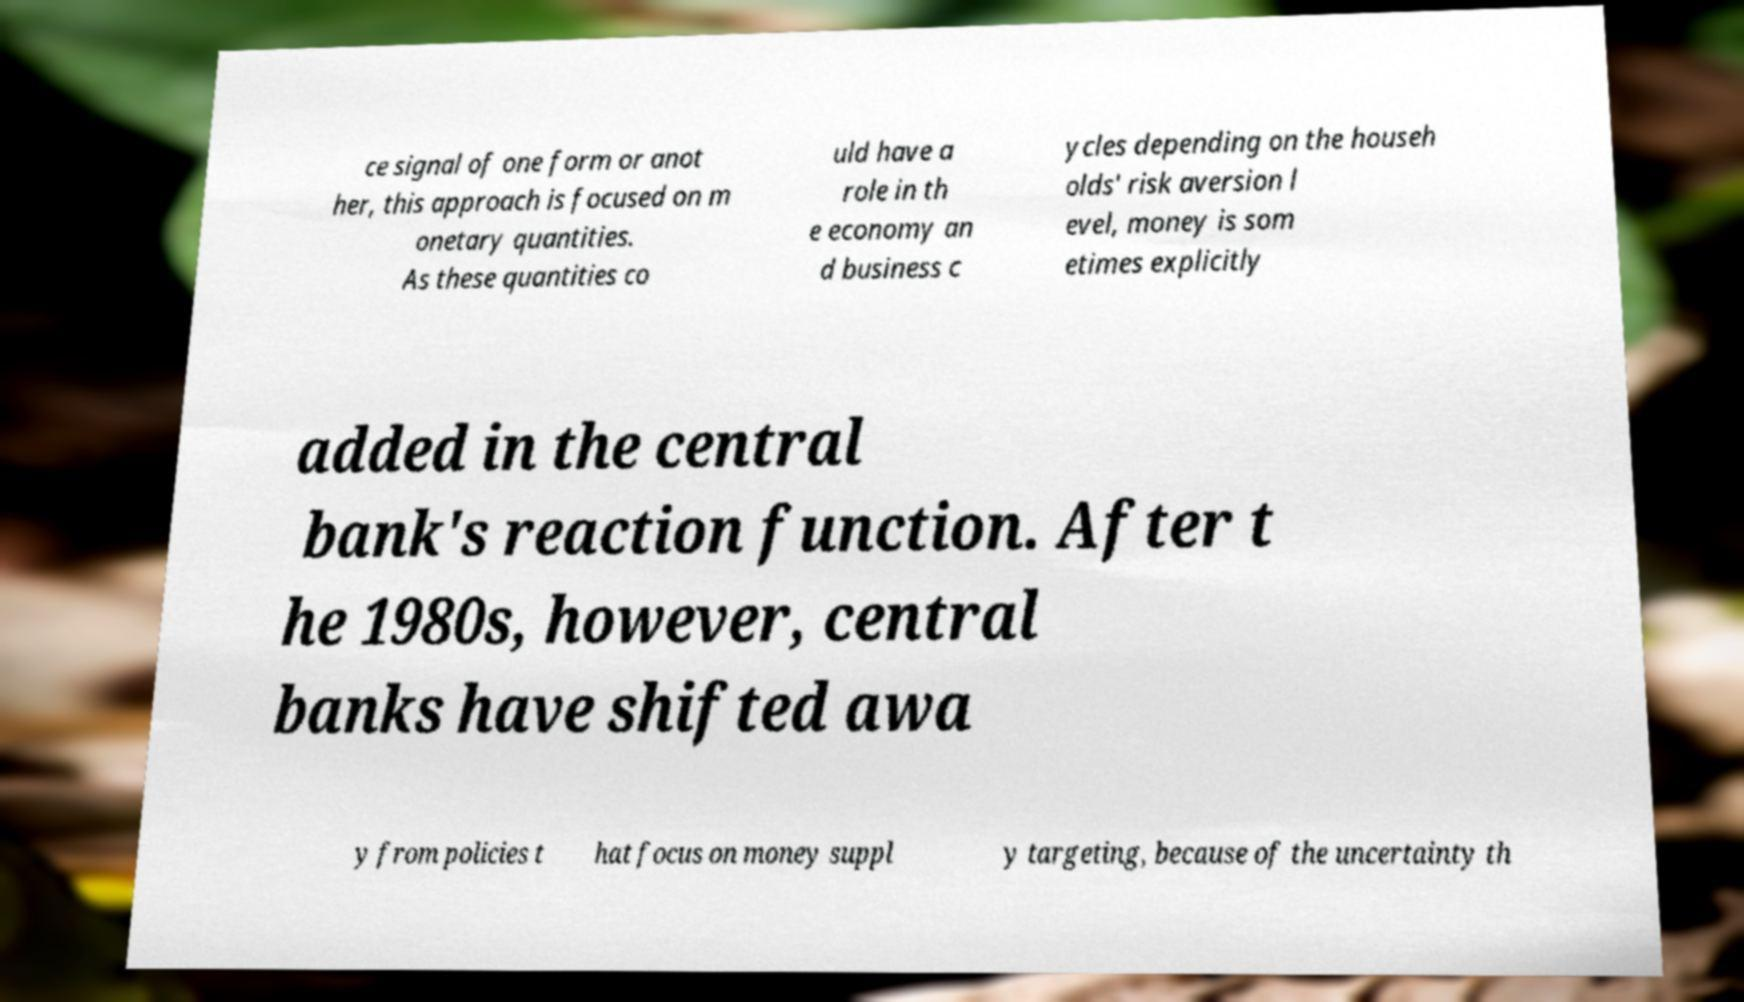What messages or text are displayed in this image? I need them in a readable, typed format. ce signal of one form or anot her, this approach is focused on m onetary quantities. As these quantities co uld have a role in th e economy an d business c ycles depending on the househ olds' risk aversion l evel, money is som etimes explicitly added in the central bank's reaction function. After t he 1980s, however, central banks have shifted awa y from policies t hat focus on money suppl y targeting, because of the uncertainty th 